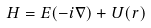Convert formula to latex. <formula><loc_0><loc_0><loc_500><loc_500>H = E ( - i \nabla ) + U ( r )</formula> 